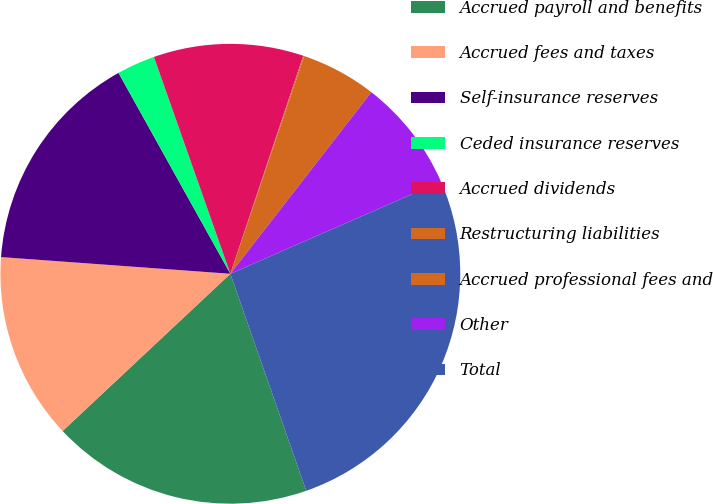Convert chart to OTSL. <chart><loc_0><loc_0><loc_500><loc_500><pie_chart><fcel>Accrued payroll and benefits<fcel>Accrued fees and taxes<fcel>Self-insurance reserves<fcel>Ceded insurance reserves<fcel>Accrued dividends<fcel>Restructuring liabilities<fcel>Accrued professional fees and<fcel>Other<fcel>Total<nl><fcel>18.37%<fcel>13.14%<fcel>15.76%<fcel>2.69%<fcel>10.53%<fcel>0.07%<fcel>5.3%<fcel>7.92%<fcel>26.22%<nl></chart> 